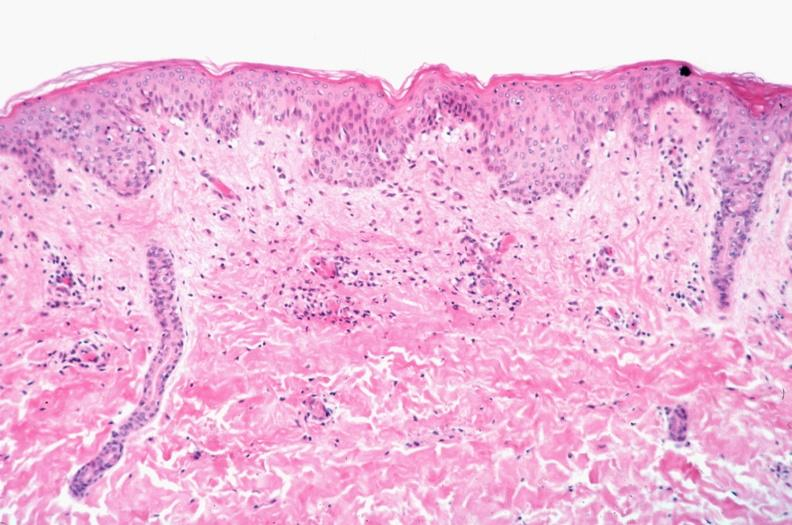does cut show skin?
Answer the question using a single word or phrase. No 